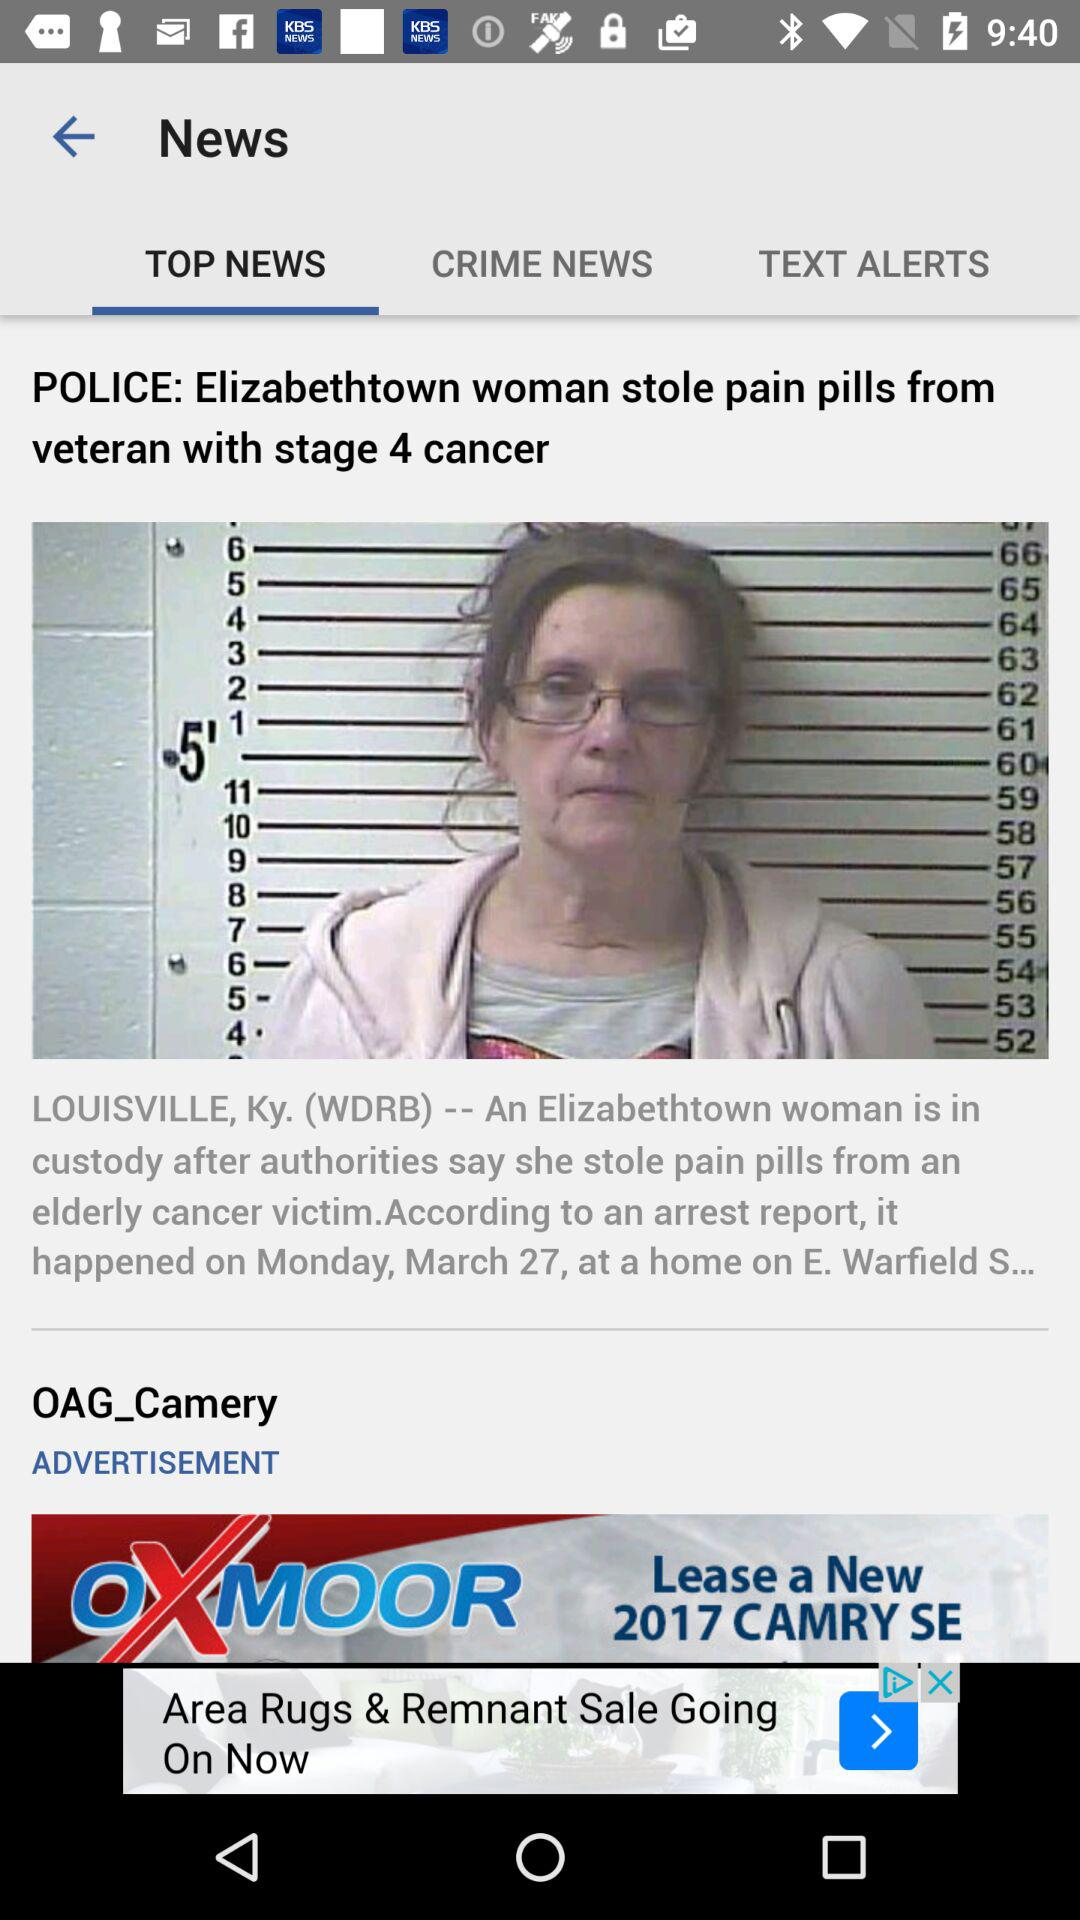Which tab of the application are we on? You are on "TOP NEWS" tab. 